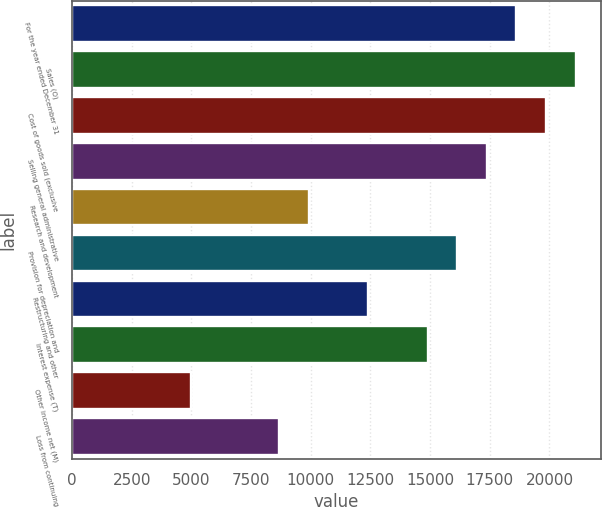Convert chart to OTSL. <chart><loc_0><loc_0><loc_500><loc_500><bar_chart><fcel>For the year ended December 31<fcel>Sales (O)<fcel>Cost of goods sold (exclusive<fcel>Selling general administrative<fcel>Research and development<fcel>Provision for depreciation and<fcel>Restructuring and other<fcel>Interest expense (T)<fcel>Other income net (M)<fcel>Loss from continuing<nl><fcel>18619.3<fcel>21101.8<fcel>19860.5<fcel>17378<fcel>9930.47<fcel>16136.8<fcel>12413<fcel>14895.5<fcel>4965.43<fcel>8689.21<nl></chart> 